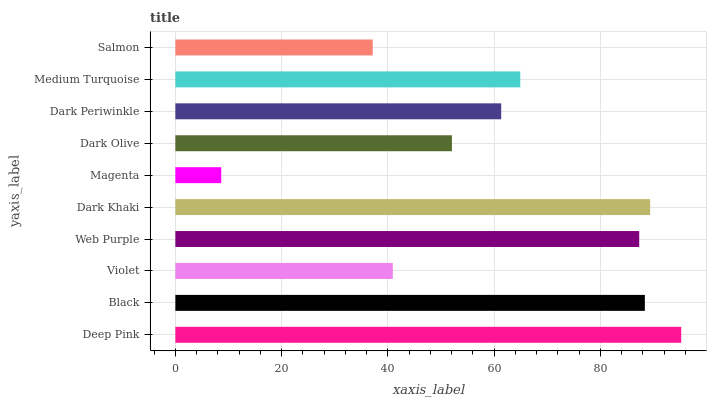Is Magenta the minimum?
Answer yes or no. Yes. Is Deep Pink the maximum?
Answer yes or no. Yes. Is Black the minimum?
Answer yes or no. No. Is Black the maximum?
Answer yes or no. No. Is Deep Pink greater than Black?
Answer yes or no. Yes. Is Black less than Deep Pink?
Answer yes or no. Yes. Is Black greater than Deep Pink?
Answer yes or no. No. Is Deep Pink less than Black?
Answer yes or no. No. Is Medium Turquoise the high median?
Answer yes or no. Yes. Is Dark Periwinkle the low median?
Answer yes or no. Yes. Is Web Purple the high median?
Answer yes or no. No. Is Deep Pink the low median?
Answer yes or no. No. 